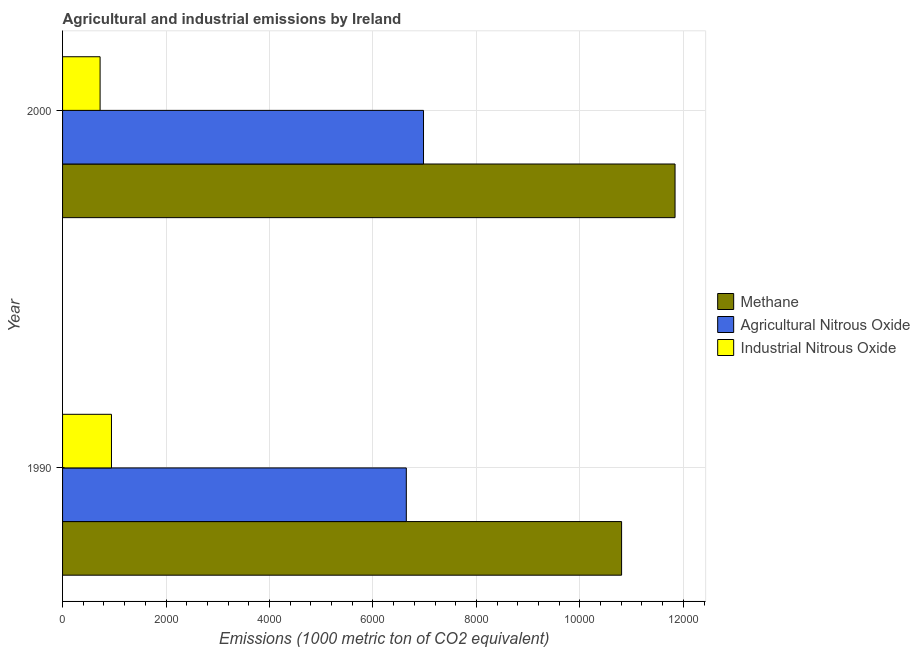How many groups of bars are there?
Provide a short and direct response. 2. Are the number of bars on each tick of the Y-axis equal?
Keep it short and to the point. Yes. How many bars are there on the 1st tick from the top?
Your answer should be compact. 3. How many bars are there on the 1st tick from the bottom?
Keep it short and to the point. 3. In how many cases, is the number of bars for a given year not equal to the number of legend labels?
Your response must be concise. 0. What is the amount of industrial nitrous oxide emissions in 2000?
Make the answer very short. 725.4. Across all years, what is the maximum amount of agricultural nitrous oxide emissions?
Your answer should be compact. 6977.3. Across all years, what is the minimum amount of agricultural nitrous oxide emissions?
Make the answer very short. 6644.8. In which year was the amount of agricultural nitrous oxide emissions maximum?
Offer a terse response. 2000. In which year was the amount of industrial nitrous oxide emissions minimum?
Your answer should be compact. 2000. What is the total amount of methane emissions in the graph?
Provide a succinct answer. 2.26e+04. What is the difference between the amount of industrial nitrous oxide emissions in 1990 and that in 2000?
Offer a terse response. 219.9. What is the difference between the amount of methane emissions in 1990 and the amount of industrial nitrous oxide emissions in 2000?
Keep it short and to the point. 1.01e+04. What is the average amount of methane emissions per year?
Give a very brief answer. 1.13e+04. In the year 2000, what is the difference between the amount of methane emissions and amount of agricultural nitrous oxide emissions?
Keep it short and to the point. 4862.3. In how many years, is the amount of industrial nitrous oxide emissions greater than 7200 metric ton?
Make the answer very short. 0. What is the ratio of the amount of methane emissions in 1990 to that in 2000?
Provide a short and direct response. 0.91. Is the difference between the amount of industrial nitrous oxide emissions in 1990 and 2000 greater than the difference between the amount of methane emissions in 1990 and 2000?
Keep it short and to the point. Yes. What does the 2nd bar from the top in 2000 represents?
Give a very brief answer. Agricultural Nitrous Oxide. What does the 2nd bar from the bottom in 1990 represents?
Provide a short and direct response. Agricultural Nitrous Oxide. Is it the case that in every year, the sum of the amount of methane emissions and amount of agricultural nitrous oxide emissions is greater than the amount of industrial nitrous oxide emissions?
Offer a terse response. Yes. How many bars are there?
Ensure brevity in your answer.  6. Are all the bars in the graph horizontal?
Ensure brevity in your answer.  Yes. How many years are there in the graph?
Your answer should be compact. 2. Does the graph contain grids?
Your answer should be very brief. Yes. Where does the legend appear in the graph?
Provide a short and direct response. Center right. How many legend labels are there?
Your response must be concise. 3. How are the legend labels stacked?
Your answer should be very brief. Vertical. What is the title of the graph?
Make the answer very short. Agricultural and industrial emissions by Ireland. Does "Services" appear as one of the legend labels in the graph?
Ensure brevity in your answer.  No. What is the label or title of the X-axis?
Your answer should be very brief. Emissions (1000 metric ton of CO2 equivalent). What is the Emissions (1000 metric ton of CO2 equivalent) of Methane in 1990?
Provide a succinct answer. 1.08e+04. What is the Emissions (1000 metric ton of CO2 equivalent) of Agricultural Nitrous Oxide in 1990?
Give a very brief answer. 6644.8. What is the Emissions (1000 metric ton of CO2 equivalent) in Industrial Nitrous Oxide in 1990?
Ensure brevity in your answer.  945.3. What is the Emissions (1000 metric ton of CO2 equivalent) in Methane in 2000?
Offer a very short reply. 1.18e+04. What is the Emissions (1000 metric ton of CO2 equivalent) in Agricultural Nitrous Oxide in 2000?
Give a very brief answer. 6977.3. What is the Emissions (1000 metric ton of CO2 equivalent) of Industrial Nitrous Oxide in 2000?
Provide a succinct answer. 725.4. Across all years, what is the maximum Emissions (1000 metric ton of CO2 equivalent) in Methane?
Your answer should be very brief. 1.18e+04. Across all years, what is the maximum Emissions (1000 metric ton of CO2 equivalent) of Agricultural Nitrous Oxide?
Provide a succinct answer. 6977.3. Across all years, what is the maximum Emissions (1000 metric ton of CO2 equivalent) of Industrial Nitrous Oxide?
Offer a very short reply. 945.3. Across all years, what is the minimum Emissions (1000 metric ton of CO2 equivalent) in Methane?
Provide a succinct answer. 1.08e+04. Across all years, what is the minimum Emissions (1000 metric ton of CO2 equivalent) in Agricultural Nitrous Oxide?
Offer a very short reply. 6644.8. Across all years, what is the minimum Emissions (1000 metric ton of CO2 equivalent) of Industrial Nitrous Oxide?
Keep it short and to the point. 725.4. What is the total Emissions (1000 metric ton of CO2 equivalent) in Methane in the graph?
Provide a succinct answer. 2.26e+04. What is the total Emissions (1000 metric ton of CO2 equivalent) in Agricultural Nitrous Oxide in the graph?
Provide a short and direct response. 1.36e+04. What is the total Emissions (1000 metric ton of CO2 equivalent) in Industrial Nitrous Oxide in the graph?
Your response must be concise. 1670.7. What is the difference between the Emissions (1000 metric ton of CO2 equivalent) in Methane in 1990 and that in 2000?
Keep it short and to the point. -1033.1. What is the difference between the Emissions (1000 metric ton of CO2 equivalent) of Agricultural Nitrous Oxide in 1990 and that in 2000?
Your answer should be compact. -332.5. What is the difference between the Emissions (1000 metric ton of CO2 equivalent) in Industrial Nitrous Oxide in 1990 and that in 2000?
Your answer should be compact. 219.9. What is the difference between the Emissions (1000 metric ton of CO2 equivalent) in Methane in 1990 and the Emissions (1000 metric ton of CO2 equivalent) in Agricultural Nitrous Oxide in 2000?
Make the answer very short. 3829.2. What is the difference between the Emissions (1000 metric ton of CO2 equivalent) of Methane in 1990 and the Emissions (1000 metric ton of CO2 equivalent) of Industrial Nitrous Oxide in 2000?
Ensure brevity in your answer.  1.01e+04. What is the difference between the Emissions (1000 metric ton of CO2 equivalent) in Agricultural Nitrous Oxide in 1990 and the Emissions (1000 metric ton of CO2 equivalent) in Industrial Nitrous Oxide in 2000?
Make the answer very short. 5919.4. What is the average Emissions (1000 metric ton of CO2 equivalent) in Methane per year?
Provide a succinct answer. 1.13e+04. What is the average Emissions (1000 metric ton of CO2 equivalent) in Agricultural Nitrous Oxide per year?
Offer a terse response. 6811.05. What is the average Emissions (1000 metric ton of CO2 equivalent) in Industrial Nitrous Oxide per year?
Ensure brevity in your answer.  835.35. In the year 1990, what is the difference between the Emissions (1000 metric ton of CO2 equivalent) in Methane and Emissions (1000 metric ton of CO2 equivalent) in Agricultural Nitrous Oxide?
Offer a very short reply. 4161.7. In the year 1990, what is the difference between the Emissions (1000 metric ton of CO2 equivalent) in Methane and Emissions (1000 metric ton of CO2 equivalent) in Industrial Nitrous Oxide?
Keep it short and to the point. 9861.2. In the year 1990, what is the difference between the Emissions (1000 metric ton of CO2 equivalent) in Agricultural Nitrous Oxide and Emissions (1000 metric ton of CO2 equivalent) in Industrial Nitrous Oxide?
Keep it short and to the point. 5699.5. In the year 2000, what is the difference between the Emissions (1000 metric ton of CO2 equivalent) of Methane and Emissions (1000 metric ton of CO2 equivalent) of Agricultural Nitrous Oxide?
Your response must be concise. 4862.3. In the year 2000, what is the difference between the Emissions (1000 metric ton of CO2 equivalent) of Methane and Emissions (1000 metric ton of CO2 equivalent) of Industrial Nitrous Oxide?
Your answer should be compact. 1.11e+04. In the year 2000, what is the difference between the Emissions (1000 metric ton of CO2 equivalent) of Agricultural Nitrous Oxide and Emissions (1000 metric ton of CO2 equivalent) of Industrial Nitrous Oxide?
Give a very brief answer. 6251.9. What is the ratio of the Emissions (1000 metric ton of CO2 equivalent) in Methane in 1990 to that in 2000?
Provide a short and direct response. 0.91. What is the ratio of the Emissions (1000 metric ton of CO2 equivalent) in Agricultural Nitrous Oxide in 1990 to that in 2000?
Offer a very short reply. 0.95. What is the ratio of the Emissions (1000 metric ton of CO2 equivalent) in Industrial Nitrous Oxide in 1990 to that in 2000?
Ensure brevity in your answer.  1.3. What is the difference between the highest and the second highest Emissions (1000 metric ton of CO2 equivalent) in Methane?
Make the answer very short. 1033.1. What is the difference between the highest and the second highest Emissions (1000 metric ton of CO2 equivalent) in Agricultural Nitrous Oxide?
Keep it short and to the point. 332.5. What is the difference between the highest and the second highest Emissions (1000 metric ton of CO2 equivalent) in Industrial Nitrous Oxide?
Make the answer very short. 219.9. What is the difference between the highest and the lowest Emissions (1000 metric ton of CO2 equivalent) of Methane?
Your response must be concise. 1033.1. What is the difference between the highest and the lowest Emissions (1000 metric ton of CO2 equivalent) of Agricultural Nitrous Oxide?
Provide a short and direct response. 332.5. What is the difference between the highest and the lowest Emissions (1000 metric ton of CO2 equivalent) of Industrial Nitrous Oxide?
Provide a succinct answer. 219.9. 